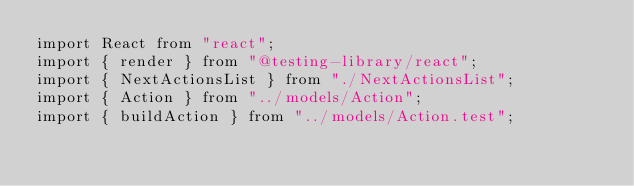Convert code to text. <code><loc_0><loc_0><loc_500><loc_500><_TypeScript_>import React from "react";
import { render } from "@testing-library/react";
import { NextActionsList } from "./NextActionsList";
import { Action } from "../models/Action";
import { buildAction } from "../models/Action.test";
</code> 